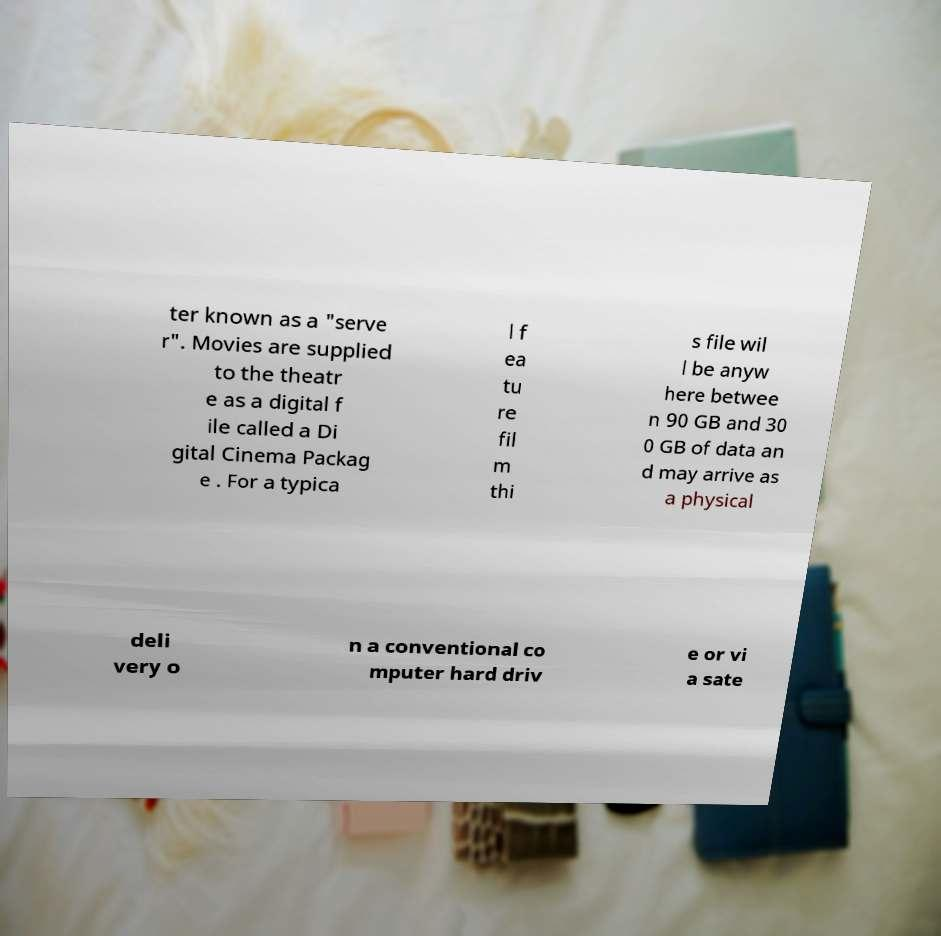I need the written content from this picture converted into text. Can you do that? ter known as a "serve r". Movies are supplied to the theatr e as a digital f ile called a Di gital Cinema Packag e . For a typica l f ea tu re fil m thi s file wil l be anyw here betwee n 90 GB and 30 0 GB of data an d may arrive as a physical deli very o n a conventional co mputer hard driv e or vi a sate 